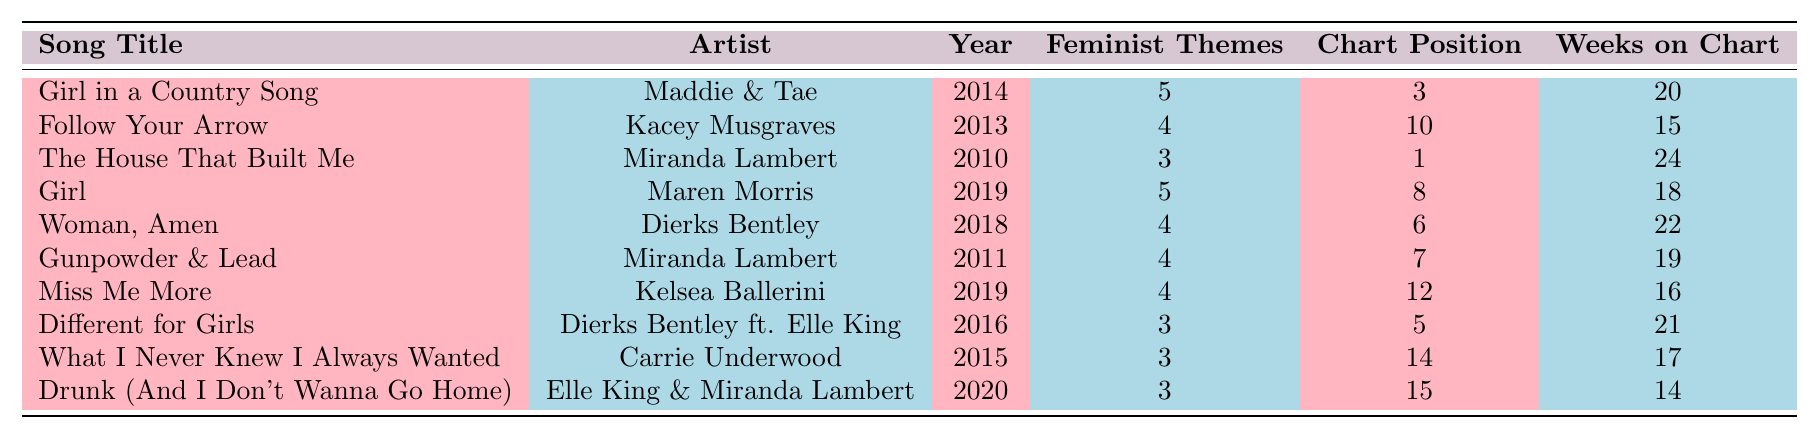What is the title of the song with the highest feminist themes? The song "Girl in a Country Song" has the highest count of feminist themes, with a value of 5.
Answer: Girl in a Country Song Which artist has the song "Follow Your Arrow"? The song "Follow Your Arrow" is performed by Kacey Musgraves.
Answer: Kacey Musgraves How many songs in the table have 3 feminist themes? There are four songs with 3 feminist themes: "The House That Built Me," "Different for Girls," "What I Never Knew I Always Wanted," and "Drunk (And I Don't Wanna Go Home)."
Answer: 4 What is the average chart position of songs that have 4 feminist themes? The chart positions for songs with 4 feminist themes are 10, 6, 7, and 12. The average is (10 + 6 + 7 + 12) / 4 = 8.75.
Answer: 8.75 Did "Gunpowder & Lead" chart higher than "Miss Me More"? "Gunpowder & Lead" charted at position 7, while "Miss Me More" charted at position 12, which means "Gunpowder & Lead" charted higher.
Answer: Yes Which song spent the most weeks on the chart and what is its feminist theme score? "The House That Built Me" spent 24 weeks on the chart and has a feminist theme score of 3.
Answer: The House That Built Me, 3 How many songs released in 2019 have 5 feminist themes? There is one song released in 2019 with 5 feminist themes, which is "Girl."
Answer: 1 What is the difference in chart positions between the songs with the highest and lowest feminist theme scores? The song with the highest score, "Girl in a Country Song," has a chart position of 3, while the song with the lowest, "The House That Built Me," has a chart position of 1. The difference is 3 - 1 = 2.
Answer: 2 List the artists who have songs with a feminist themes score of 4. The artists with songs scoring 4 feminist themes are Kacey Musgraves, Dierks Bentley, Miranda Lambert, and Kelsea Ballerini.
Answer: Kacey Musgraves, Dierks Bentley, Miranda Lambert, Kelsea Ballerini What is the highest number of weeks any song spent on the chart, and which song is it? "The House That Built Me" spent the most weeks on the chart at 24 weeks.
Answer: The House That Built Me, 24 weeks 